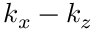<formula> <loc_0><loc_0><loc_500><loc_500>k _ { x } - k _ { z }</formula> 